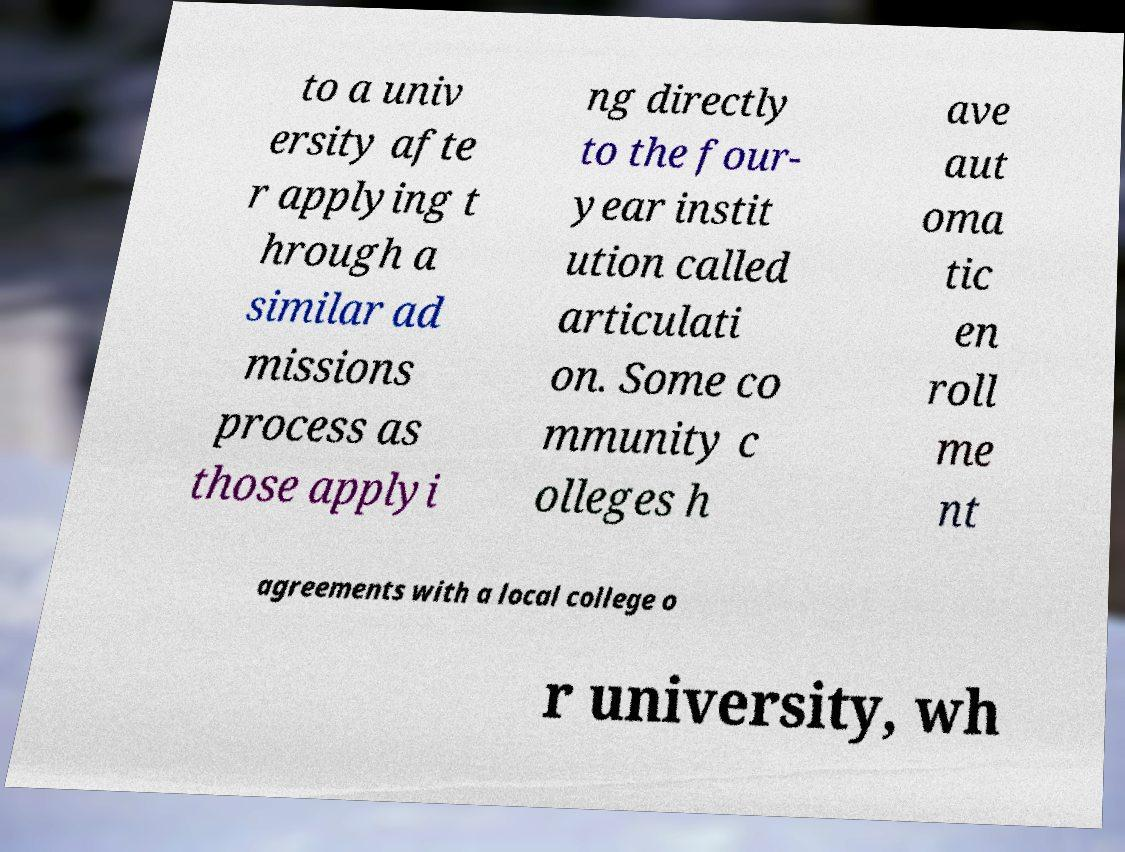I need the written content from this picture converted into text. Can you do that? to a univ ersity afte r applying t hrough a similar ad missions process as those applyi ng directly to the four- year instit ution called articulati on. Some co mmunity c olleges h ave aut oma tic en roll me nt agreements with a local college o r university, wh 